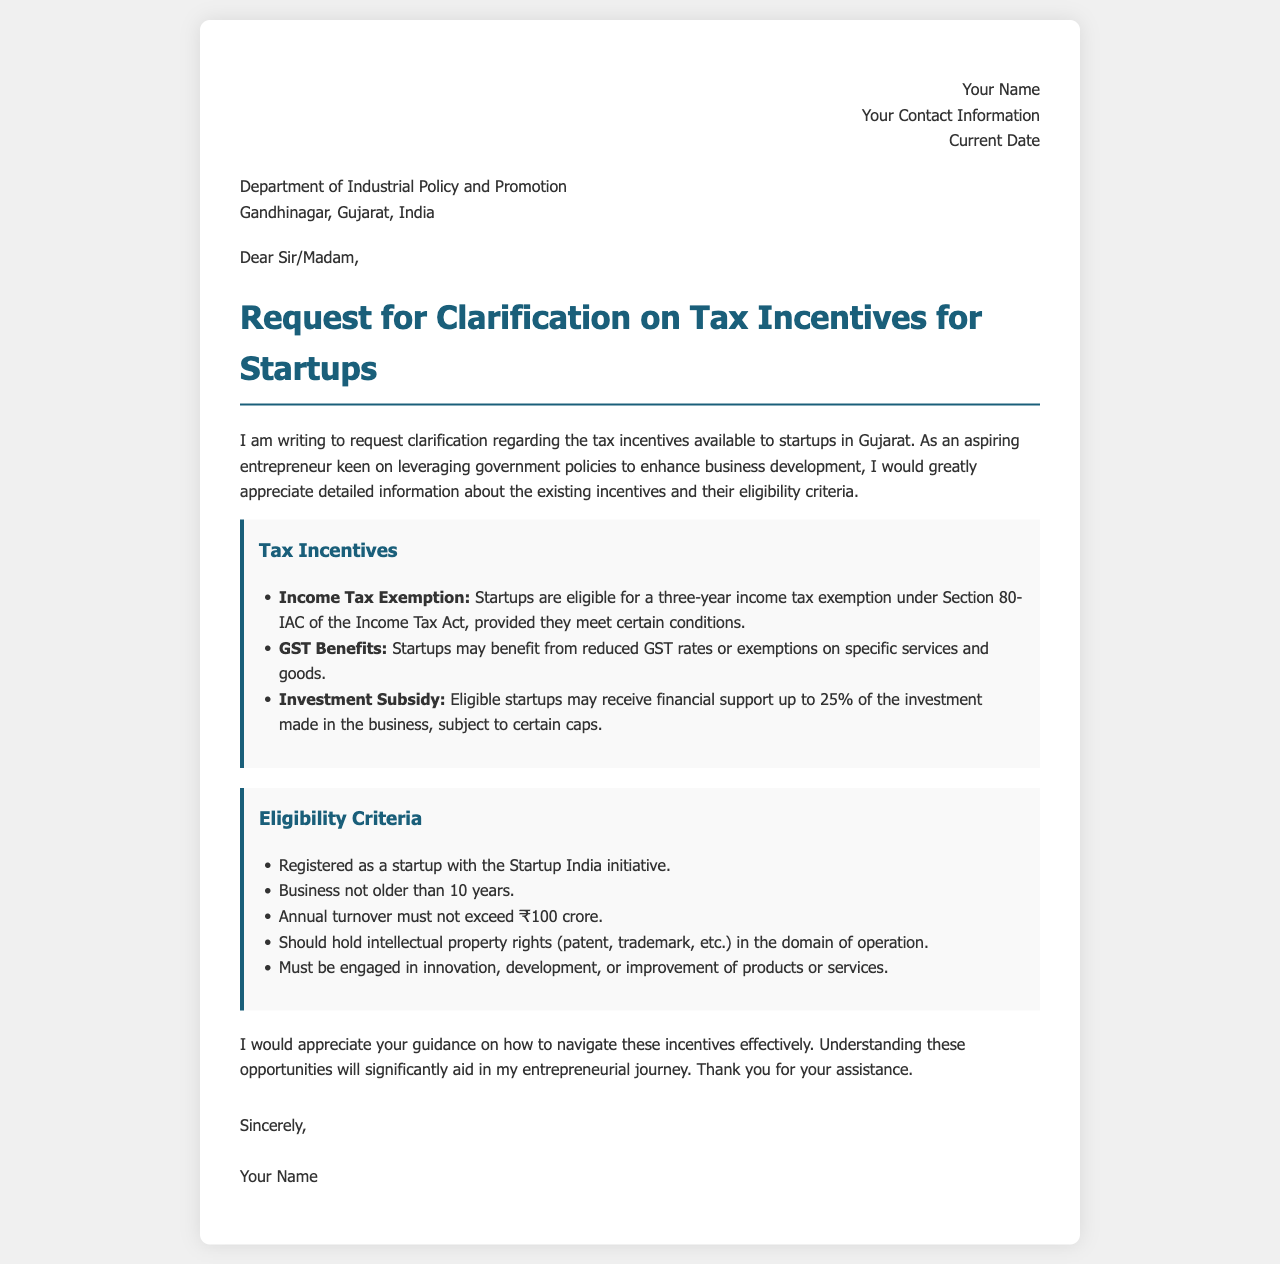What is the title of the letter? The title of the letter is usually stated prominently beneath the greeting, indicating the purpose of the correspondence.
Answer: Request for Clarification on Tax Incentives for Startups What is the address of the department being contacted? The address provided in the letter states the specific organization and its location for correspondence.
Answer: Department of Industrial Policy and Promotion, Gandhinagar, Gujarat, India What is the maximum annual turnover allowed for startups to be eligible for tax incentives? The eligibility criteria specify the maximum annual turnover for startups seeking benefits under the provided schemes.
Answer: ₹100 crore How many years of income tax exemption can startups receive? The document mentions specific benefits related to income tax, including the duration of such exemptions for eligible startups.
Answer: Three years What percentage of investment may eligible startups receive as an investment subsidy? The tax incentives outline potential financial support for startups based on their investments, specifying the percentage they may receive.
Answer: 25% What is one requirement concerning intellectual property rights for startups? Eligibility criteria include specific requirements for startups regarding the ownership of intellectual property.
Answer: Hold intellectual property rights (patent, trademark, etc.) What is the maximum age of a startup to qualify for tax incentives? The letter outlines the age restriction for businesses to ensure they are within the qualifying timeframe for tax incentives.
Answer: 10 years What type of letter is this document classified as? The structure and content of the document indicate its formal function in requesting specific information from an organization.
Answer: Request Letter 